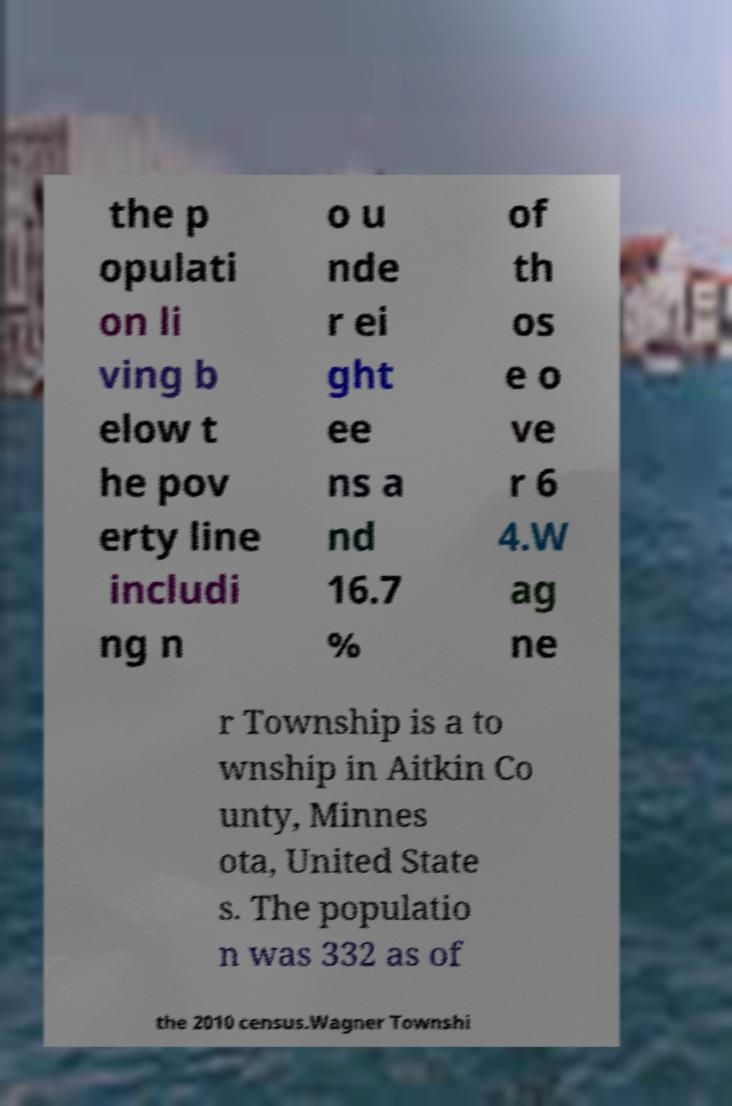There's text embedded in this image that I need extracted. Can you transcribe it verbatim? the p opulati on li ving b elow t he pov erty line includi ng n o u nde r ei ght ee ns a nd 16.7 % of th os e o ve r 6 4.W ag ne r Township is a to wnship in Aitkin Co unty, Minnes ota, United State s. The populatio n was 332 as of the 2010 census.Wagner Townshi 